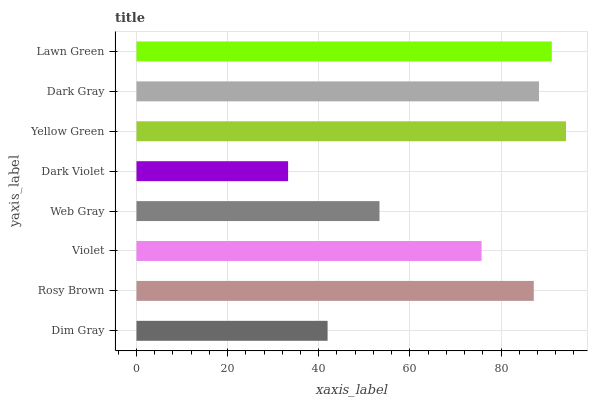Is Dark Violet the minimum?
Answer yes or no. Yes. Is Yellow Green the maximum?
Answer yes or no. Yes. Is Rosy Brown the minimum?
Answer yes or no. No. Is Rosy Brown the maximum?
Answer yes or no. No. Is Rosy Brown greater than Dim Gray?
Answer yes or no. Yes. Is Dim Gray less than Rosy Brown?
Answer yes or no. Yes. Is Dim Gray greater than Rosy Brown?
Answer yes or no. No. Is Rosy Brown less than Dim Gray?
Answer yes or no. No. Is Rosy Brown the high median?
Answer yes or no. Yes. Is Violet the low median?
Answer yes or no. Yes. Is Yellow Green the high median?
Answer yes or no. No. Is Dark Violet the low median?
Answer yes or no. No. 